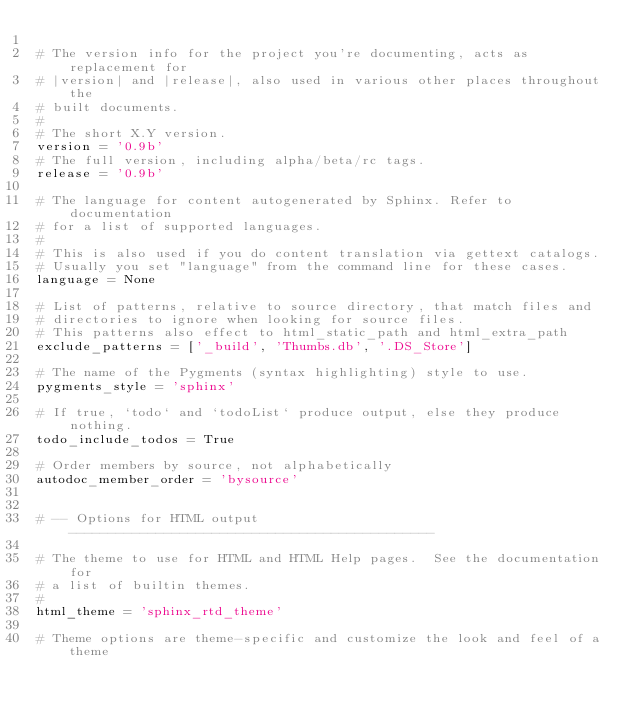<code> <loc_0><loc_0><loc_500><loc_500><_Python_>
# The version info for the project you're documenting, acts as replacement for
# |version| and |release|, also used in various other places throughout the
# built documents.
#
# The short X.Y version.
version = '0.9b'
# The full version, including alpha/beta/rc tags.
release = '0.9b'

# The language for content autogenerated by Sphinx. Refer to documentation
# for a list of supported languages.
#
# This is also used if you do content translation via gettext catalogs.
# Usually you set "language" from the command line for these cases.
language = None

# List of patterns, relative to source directory, that match files and
# directories to ignore when looking for source files.
# This patterns also effect to html_static_path and html_extra_path
exclude_patterns = ['_build', 'Thumbs.db', '.DS_Store']

# The name of the Pygments (syntax highlighting) style to use.
pygments_style = 'sphinx'

# If true, `todo` and `todoList` produce output, else they produce nothing.
todo_include_todos = True

# Order members by source, not alphabetically
autodoc_member_order = 'bysource'


# -- Options for HTML output ----------------------------------------------

# The theme to use for HTML and HTML Help pages.  See the documentation for
# a list of builtin themes.
#
html_theme = 'sphinx_rtd_theme'

# Theme options are theme-specific and customize the look and feel of a theme</code> 